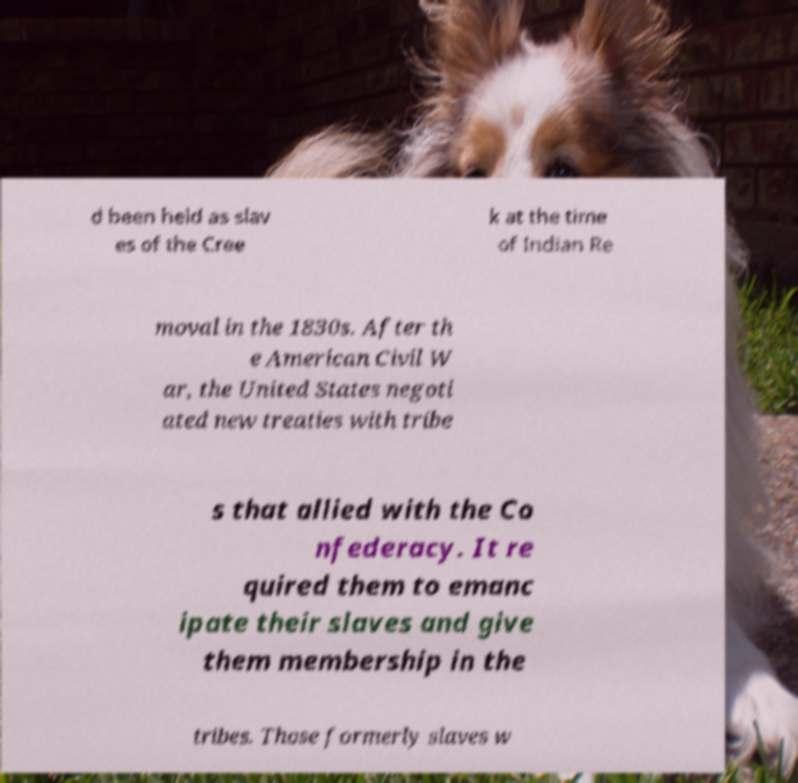Please read and relay the text visible in this image. What does it say? d been held as slav es of the Cree k at the time of Indian Re moval in the 1830s. After th e American Civil W ar, the United States negoti ated new treaties with tribe s that allied with the Co nfederacy. It re quired them to emanc ipate their slaves and give them membership in the tribes. Those formerly slaves w 